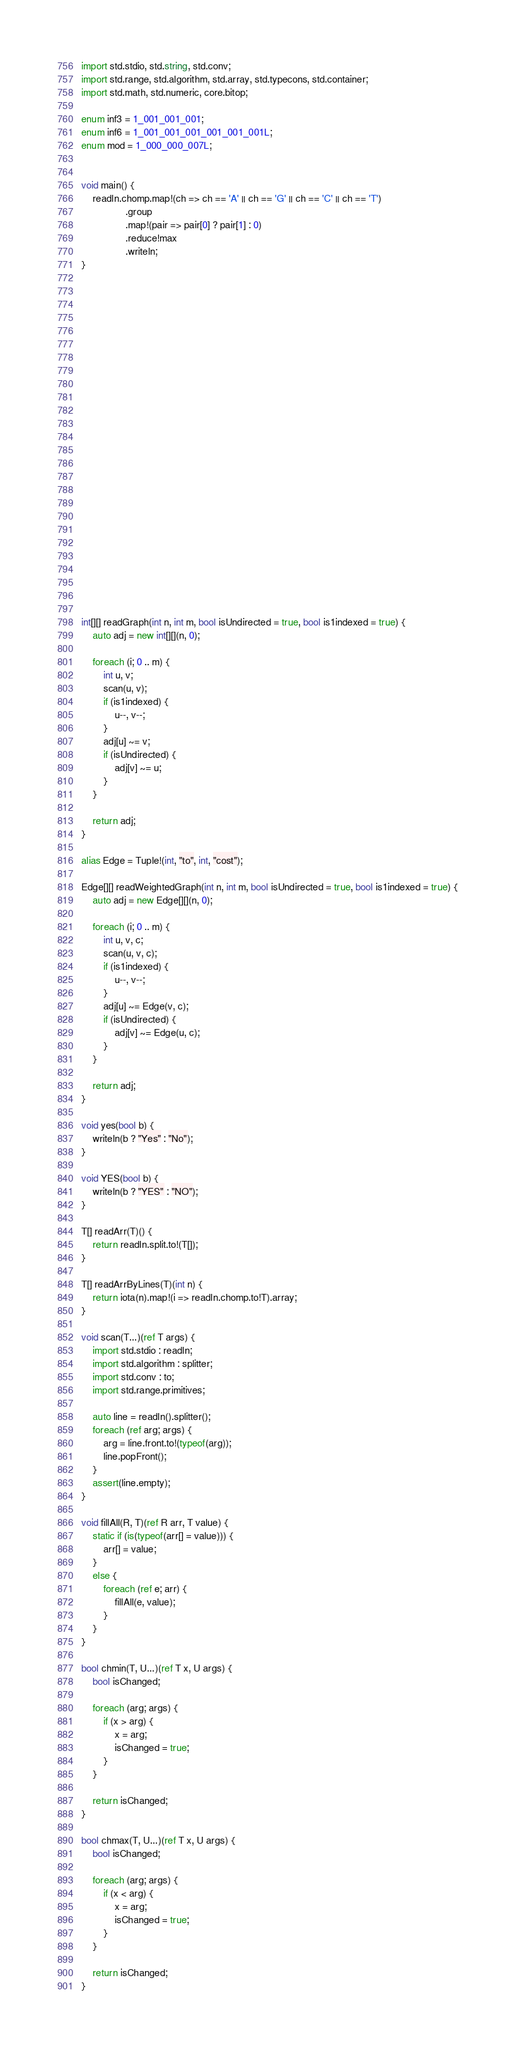Convert code to text. <code><loc_0><loc_0><loc_500><loc_500><_D_>import std.stdio, std.string, std.conv;
import std.range, std.algorithm, std.array, std.typecons, std.container;
import std.math, std.numeric, core.bitop;

enum inf3 = 1_001_001_001;
enum inf6 = 1_001_001_001_001_001_001L;
enum mod = 1_000_000_007L;


void main() {
    readln.chomp.map!(ch => ch == 'A' || ch == 'G' || ch == 'C' || ch == 'T')
                .group
                .map!(pair => pair[0] ? pair[1] : 0)
                .reduce!max
                .writeln;
}


























int[][] readGraph(int n, int m, bool isUndirected = true, bool is1indexed = true) {
    auto adj = new int[][](n, 0);

    foreach (i; 0 .. m) {
        int u, v;
        scan(u, v);
        if (is1indexed) {
            u--, v--;
        }
        adj[u] ~= v;
        if (isUndirected) {
            adj[v] ~= u;
        }
    }

    return adj;
}

alias Edge = Tuple!(int, "to", int, "cost");

Edge[][] readWeightedGraph(int n, int m, bool isUndirected = true, bool is1indexed = true) {
    auto adj = new Edge[][](n, 0);

    foreach (i; 0 .. m) {
        int u, v, c;
        scan(u, v, c);
        if (is1indexed) {
            u--, v--;
        }
        adj[u] ~= Edge(v, c);
        if (isUndirected) {
            adj[v] ~= Edge(u, c);
        }
    }

    return adj;
}

void yes(bool b) {
    writeln(b ? "Yes" : "No");
}

void YES(bool b) {
    writeln(b ? "YES" : "NO");
}

T[] readArr(T)() {
    return readln.split.to!(T[]);
}

T[] readArrByLines(T)(int n) {
    return iota(n).map!(i => readln.chomp.to!T).array;
}

void scan(T...)(ref T args) {
    import std.stdio : readln;
    import std.algorithm : splitter;
    import std.conv : to;
    import std.range.primitives;

    auto line = readln().splitter();
    foreach (ref arg; args) {
        arg = line.front.to!(typeof(arg));
        line.popFront();
    }
    assert(line.empty);
}

void fillAll(R, T)(ref R arr, T value) {
    static if (is(typeof(arr[] = value))) {
        arr[] = value;
    }
    else {
        foreach (ref e; arr) {
            fillAll(e, value);
        }
    }
}

bool chmin(T, U...)(ref T x, U args) {
    bool isChanged;

    foreach (arg; args) {
        if (x > arg) {
            x = arg;
            isChanged = true;
        }
    }

    return isChanged;
}

bool chmax(T, U...)(ref T x, U args) {
    bool isChanged;

    foreach (arg; args) {
        if (x < arg) {
            x = arg;
            isChanged = true;
        }
    }

    return isChanged;
}
</code> 